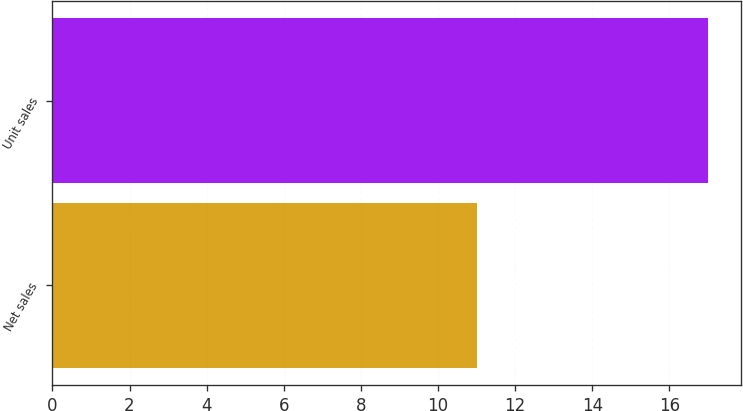Convert chart to OTSL. <chart><loc_0><loc_0><loc_500><loc_500><bar_chart><fcel>Net sales<fcel>Unit sales<nl><fcel>11<fcel>17<nl></chart> 